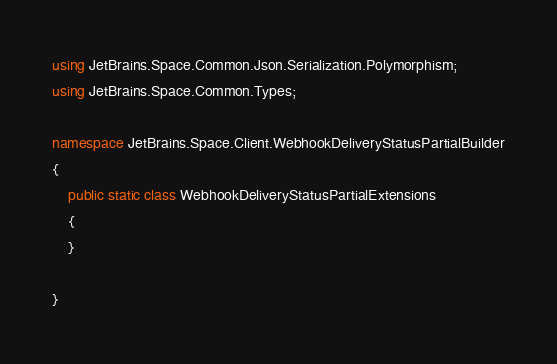<code> <loc_0><loc_0><loc_500><loc_500><_C#_>using JetBrains.Space.Common.Json.Serialization.Polymorphism;
using JetBrains.Space.Common.Types;

namespace JetBrains.Space.Client.WebhookDeliveryStatusPartialBuilder
{
    public static class WebhookDeliveryStatusPartialExtensions
    {
    }
    
}
</code> 